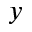Convert formula to latex. <formula><loc_0><loc_0><loc_500><loc_500>y</formula> 